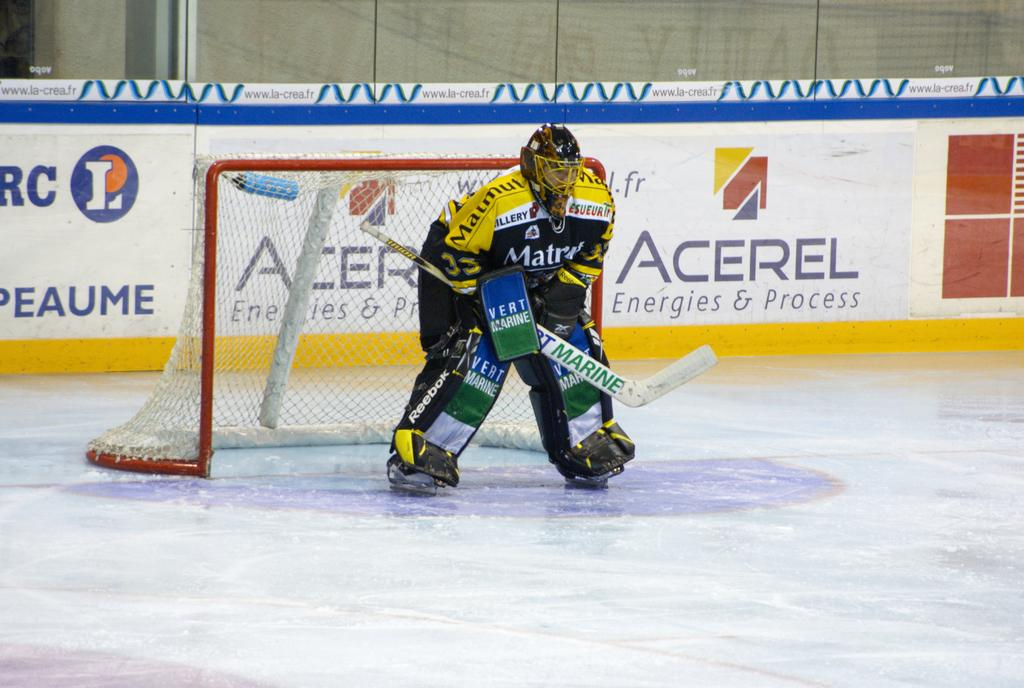What is the main subject of the image? There is a person in the image. What is the person doing in the image? The person is standing on the ground and holding a bat. What protective gear is the person wearing? The person is wearing a helmet and a knee pad. What other objects or structures can be seen in the image? There is a goal post, a board with text, and a wall in the image. How many rabbits can be seen playing with a crayon in the image? There are no rabbits or crayons present in the image. What type of border is visible around the wall in the image? There is no mention of a border around the wall in the image. 